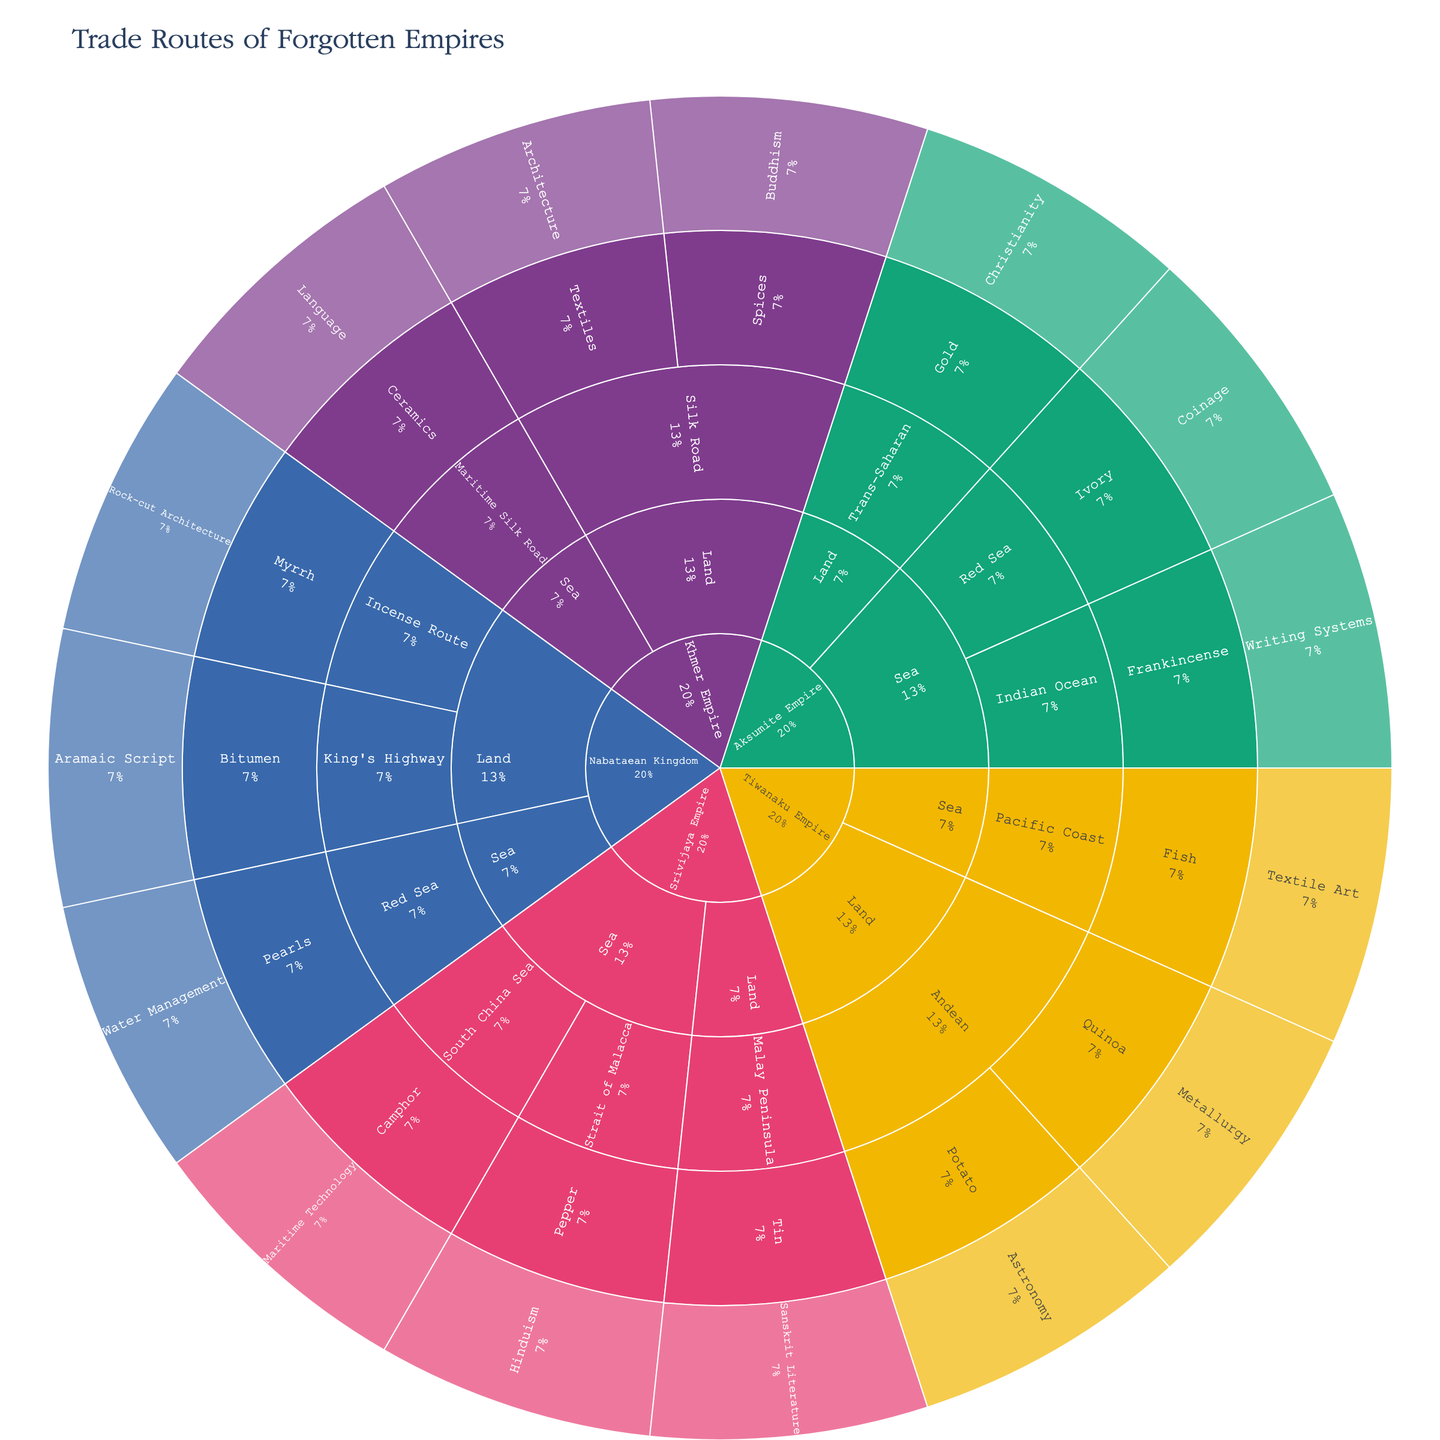What is the main title of the figure? The title is usually prominently displayed at the top of a figure. It provides an overview of what the figure represents. In this case, it's written in the code used to create the figure.
Answer: Trade Routes of Forgotten Empires Which empire has the highest number of routes displayed in the sunburst plot? Count the number of segments under each empire. Khmer Empire, Aksumite Empire, Tiwanaku Empire, Srivijaya Empire, and Nabataean Kingdom all have several sections under them.
Answer: Srivijaya Empire What commodities were traded through the Silk Road under the Khmer Empire? Identify the Khmer Empire in the sunburst plot. Under the route type "Land" and path "Silk Road," you will find the commodities.
Answer: Spices, Textiles How many distinct trade paths are shown for the Aksumite Empire? Locate the Aksumite Empire in the sunburst plot and count the different paths branching out under both "Land" and "Sea" route types.
Answer: 3 What cultural influence is associated with bitumen in the Nabataean Kingdom? Look for the Nabataean Kingdom in the sunburst plot, then track down to the commodity "Bitumen" and identify the corresponding cultural influence.
Answer: Aramaic Script Which trade route under the Srivijaya Empire is linked to Maritime Technology? Find the Srivijaya Empire section in the plot, look for the detailed path "South China Sea" under the "Sea" route and find its cultural influence.
Answer: South China Sea For the Tiwanaku Empire, list the commodities traded through the Andean path and their associated cultural influences. Locate the Tiwanaku Empire, then under "Land" and "Andean" path, list the commodities and their corresponding cultural influences.
Answer: Potato - Astronomy, Quinoa - Metallurgy Compare the number of sea routes between the Aksumite Empire and the Srivijaya Empire. Count the number of sea route paths for both Aksumite Empire and Srivijaya Empire in the sunburst plot and compare them.
Answer: Aksumite Empire: 2, Srivijaya Empire: 3 Which empire has the route involving the commodity 'Myrrh'? Scan through the empires in the sunburst plot, and identify the one with the commodity 'Myrrh' under their trade routes.
Answer: Nabataean Kingdom 